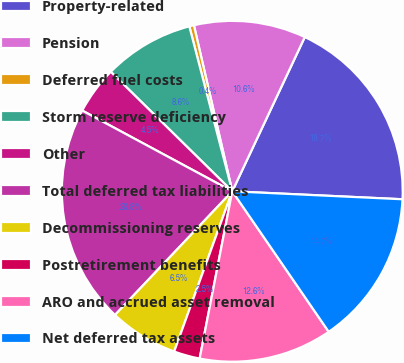<chart> <loc_0><loc_0><loc_500><loc_500><pie_chart><fcel>Property-related<fcel>Pension<fcel>Deferred fuel costs<fcel>Storm reserve deficiency<fcel>Other<fcel>Total deferred tax liabilities<fcel>Decommissioning reserves<fcel>Postretirement benefits<fcel>ARO and accrued asset removal<fcel>Net deferred tax assets<nl><fcel>18.75%<fcel>10.61%<fcel>0.44%<fcel>8.58%<fcel>4.51%<fcel>20.78%<fcel>6.54%<fcel>2.47%<fcel>12.64%<fcel>14.68%<nl></chart> 